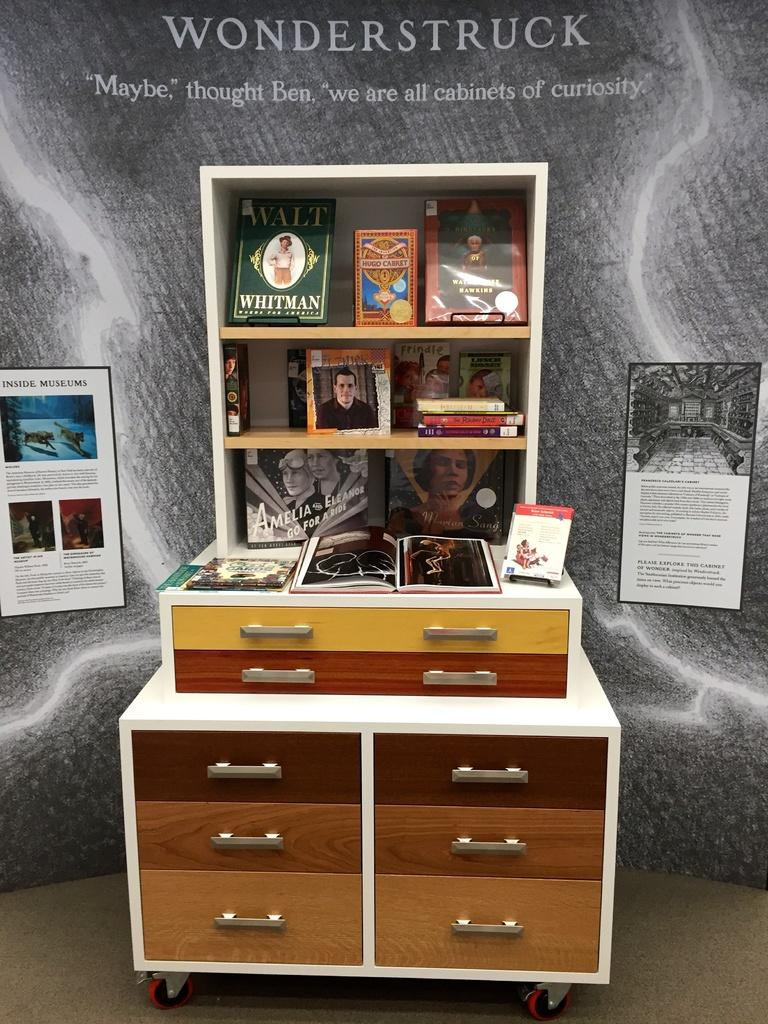What is located in the middle of the image? There is a table in the middle of the image. What objects are on the table? There are books on the table. What can be seen behind the table? There are posters behind the table. How many spiders are crawling on the books in the image? There are no spiders visible in the image; it only shows books on a table with posters behind it. 